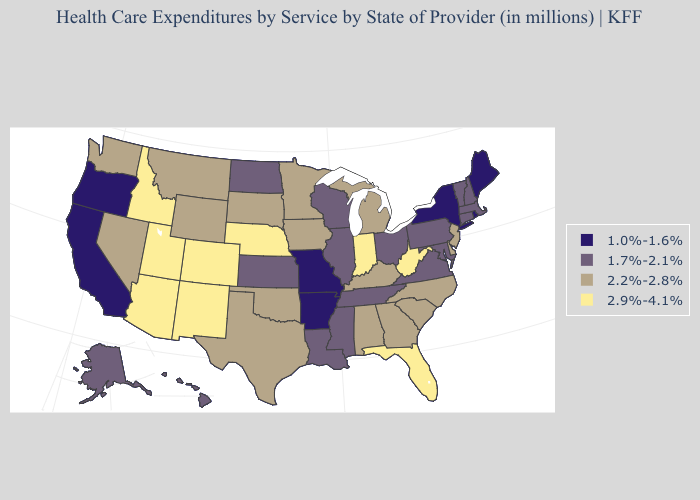What is the highest value in the West ?
Short answer required. 2.9%-4.1%. Name the states that have a value in the range 1.7%-2.1%?
Concise answer only. Alaska, Connecticut, Hawaii, Illinois, Kansas, Louisiana, Maryland, Massachusetts, Mississippi, New Hampshire, North Dakota, Ohio, Pennsylvania, Tennessee, Vermont, Virginia, Wisconsin. Does New Mexico have a lower value than Texas?
Give a very brief answer. No. Which states have the lowest value in the South?
Quick response, please. Arkansas. Does Alabama have a lower value than West Virginia?
Keep it brief. Yes. What is the value of Connecticut?
Quick response, please. 1.7%-2.1%. Name the states that have a value in the range 2.9%-4.1%?
Give a very brief answer. Arizona, Colorado, Florida, Idaho, Indiana, Nebraska, New Mexico, Utah, West Virginia. Does Illinois have the highest value in the MidWest?
Answer briefly. No. Among the states that border Georgia , does Florida have the highest value?
Answer briefly. Yes. Does Virginia have the same value as Ohio?
Write a very short answer. Yes. What is the value of Georgia?
Concise answer only. 2.2%-2.8%. What is the highest value in the West ?
Keep it brief. 2.9%-4.1%. What is the value of Texas?
Write a very short answer. 2.2%-2.8%. Does California have the highest value in the West?
Give a very brief answer. No. What is the value of Alabama?
Answer briefly. 2.2%-2.8%. 